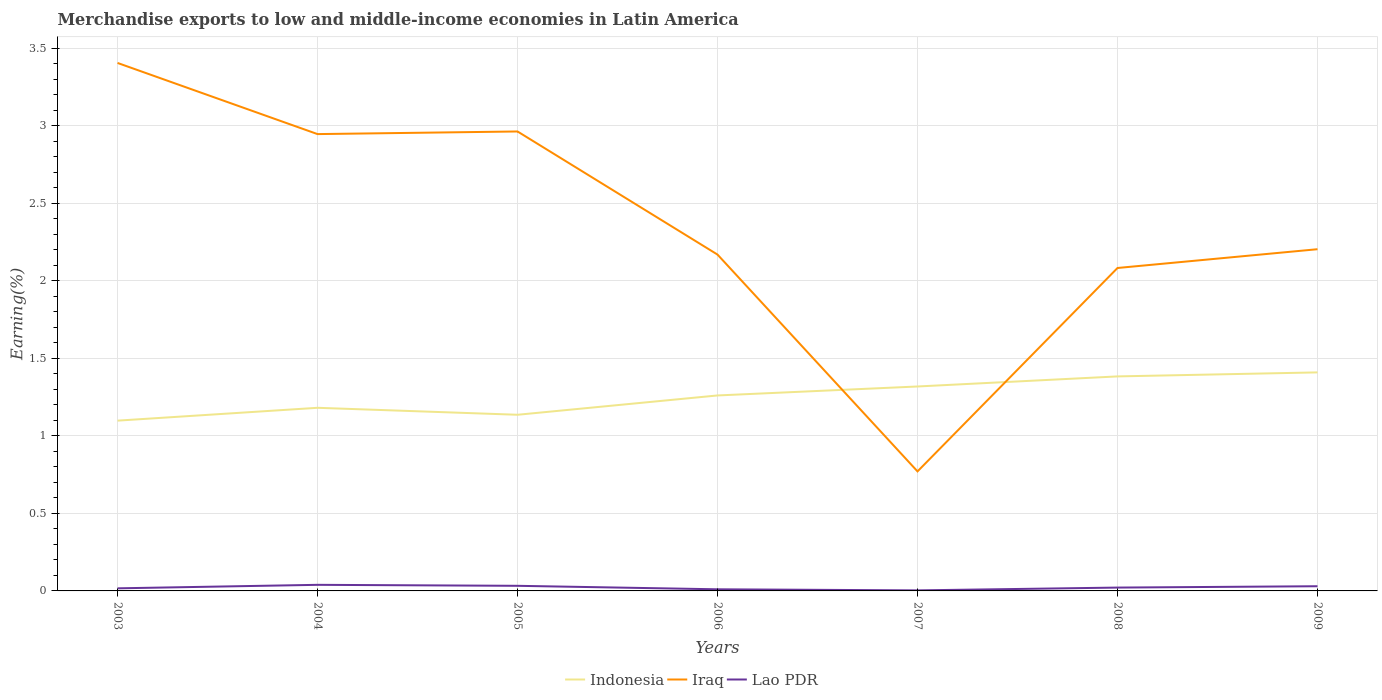Is the number of lines equal to the number of legend labels?
Make the answer very short. Yes. Across all years, what is the maximum percentage of amount earned from merchandise exports in Lao PDR?
Ensure brevity in your answer.  0. What is the total percentage of amount earned from merchandise exports in Iraq in the graph?
Your answer should be very brief. 2.63. What is the difference between the highest and the second highest percentage of amount earned from merchandise exports in Lao PDR?
Keep it short and to the point. 0.04. Is the percentage of amount earned from merchandise exports in Indonesia strictly greater than the percentage of amount earned from merchandise exports in Lao PDR over the years?
Provide a short and direct response. No. How many lines are there?
Make the answer very short. 3. How many years are there in the graph?
Your answer should be compact. 7. Does the graph contain any zero values?
Give a very brief answer. No. Does the graph contain grids?
Your answer should be compact. Yes. Where does the legend appear in the graph?
Give a very brief answer. Bottom center. How are the legend labels stacked?
Give a very brief answer. Horizontal. What is the title of the graph?
Your response must be concise. Merchandise exports to low and middle-income economies in Latin America. What is the label or title of the Y-axis?
Keep it short and to the point. Earning(%). What is the Earning(%) of Indonesia in 2003?
Provide a short and direct response. 1.1. What is the Earning(%) of Iraq in 2003?
Provide a short and direct response. 3.41. What is the Earning(%) in Lao PDR in 2003?
Your answer should be very brief. 0.02. What is the Earning(%) in Indonesia in 2004?
Provide a short and direct response. 1.18. What is the Earning(%) of Iraq in 2004?
Ensure brevity in your answer.  2.95. What is the Earning(%) of Lao PDR in 2004?
Keep it short and to the point. 0.04. What is the Earning(%) of Indonesia in 2005?
Your response must be concise. 1.14. What is the Earning(%) in Iraq in 2005?
Provide a short and direct response. 2.96. What is the Earning(%) of Lao PDR in 2005?
Offer a terse response. 0.03. What is the Earning(%) in Indonesia in 2006?
Your answer should be compact. 1.26. What is the Earning(%) of Iraq in 2006?
Offer a very short reply. 2.17. What is the Earning(%) in Lao PDR in 2006?
Provide a short and direct response. 0.01. What is the Earning(%) of Indonesia in 2007?
Give a very brief answer. 1.32. What is the Earning(%) in Iraq in 2007?
Your answer should be very brief. 0.77. What is the Earning(%) in Lao PDR in 2007?
Offer a terse response. 0. What is the Earning(%) of Indonesia in 2008?
Offer a very short reply. 1.38. What is the Earning(%) of Iraq in 2008?
Offer a terse response. 2.08. What is the Earning(%) of Lao PDR in 2008?
Provide a short and direct response. 0.02. What is the Earning(%) in Indonesia in 2009?
Keep it short and to the point. 1.41. What is the Earning(%) of Iraq in 2009?
Your answer should be compact. 2.2. What is the Earning(%) of Lao PDR in 2009?
Your response must be concise. 0.03. Across all years, what is the maximum Earning(%) of Indonesia?
Your response must be concise. 1.41. Across all years, what is the maximum Earning(%) of Iraq?
Your answer should be very brief. 3.41. Across all years, what is the maximum Earning(%) of Lao PDR?
Ensure brevity in your answer.  0.04. Across all years, what is the minimum Earning(%) in Indonesia?
Your response must be concise. 1.1. Across all years, what is the minimum Earning(%) of Iraq?
Give a very brief answer. 0.77. Across all years, what is the minimum Earning(%) of Lao PDR?
Your response must be concise. 0. What is the total Earning(%) of Indonesia in the graph?
Keep it short and to the point. 8.79. What is the total Earning(%) in Iraq in the graph?
Make the answer very short. 16.54. What is the total Earning(%) in Lao PDR in the graph?
Offer a very short reply. 0.15. What is the difference between the Earning(%) of Indonesia in 2003 and that in 2004?
Provide a short and direct response. -0.08. What is the difference between the Earning(%) in Iraq in 2003 and that in 2004?
Provide a short and direct response. 0.46. What is the difference between the Earning(%) of Lao PDR in 2003 and that in 2004?
Provide a short and direct response. -0.02. What is the difference between the Earning(%) of Indonesia in 2003 and that in 2005?
Keep it short and to the point. -0.04. What is the difference between the Earning(%) of Iraq in 2003 and that in 2005?
Your answer should be very brief. 0.44. What is the difference between the Earning(%) of Lao PDR in 2003 and that in 2005?
Offer a very short reply. -0.02. What is the difference between the Earning(%) of Indonesia in 2003 and that in 2006?
Offer a terse response. -0.16. What is the difference between the Earning(%) of Iraq in 2003 and that in 2006?
Ensure brevity in your answer.  1.24. What is the difference between the Earning(%) in Lao PDR in 2003 and that in 2006?
Provide a succinct answer. 0.01. What is the difference between the Earning(%) in Indonesia in 2003 and that in 2007?
Make the answer very short. -0.22. What is the difference between the Earning(%) of Iraq in 2003 and that in 2007?
Your answer should be compact. 2.63. What is the difference between the Earning(%) in Lao PDR in 2003 and that in 2007?
Your answer should be compact. 0.01. What is the difference between the Earning(%) in Indonesia in 2003 and that in 2008?
Your answer should be very brief. -0.29. What is the difference between the Earning(%) in Iraq in 2003 and that in 2008?
Provide a succinct answer. 1.32. What is the difference between the Earning(%) in Lao PDR in 2003 and that in 2008?
Offer a terse response. -0. What is the difference between the Earning(%) in Indonesia in 2003 and that in 2009?
Your answer should be compact. -0.31. What is the difference between the Earning(%) of Iraq in 2003 and that in 2009?
Your response must be concise. 1.2. What is the difference between the Earning(%) of Lao PDR in 2003 and that in 2009?
Provide a short and direct response. -0.01. What is the difference between the Earning(%) in Indonesia in 2004 and that in 2005?
Keep it short and to the point. 0.04. What is the difference between the Earning(%) in Iraq in 2004 and that in 2005?
Provide a succinct answer. -0.02. What is the difference between the Earning(%) of Lao PDR in 2004 and that in 2005?
Offer a terse response. 0.01. What is the difference between the Earning(%) in Indonesia in 2004 and that in 2006?
Your answer should be compact. -0.08. What is the difference between the Earning(%) of Iraq in 2004 and that in 2006?
Your answer should be compact. 0.78. What is the difference between the Earning(%) of Lao PDR in 2004 and that in 2006?
Offer a terse response. 0.03. What is the difference between the Earning(%) of Indonesia in 2004 and that in 2007?
Your answer should be compact. -0.14. What is the difference between the Earning(%) in Iraq in 2004 and that in 2007?
Provide a succinct answer. 2.18. What is the difference between the Earning(%) in Lao PDR in 2004 and that in 2007?
Ensure brevity in your answer.  0.04. What is the difference between the Earning(%) in Indonesia in 2004 and that in 2008?
Your response must be concise. -0.2. What is the difference between the Earning(%) of Iraq in 2004 and that in 2008?
Keep it short and to the point. 0.86. What is the difference between the Earning(%) of Lao PDR in 2004 and that in 2008?
Provide a succinct answer. 0.02. What is the difference between the Earning(%) of Indonesia in 2004 and that in 2009?
Your answer should be compact. -0.23. What is the difference between the Earning(%) of Iraq in 2004 and that in 2009?
Keep it short and to the point. 0.74. What is the difference between the Earning(%) in Lao PDR in 2004 and that in 2009?
Your answer should be compact. 0.01. What is the difference between the Earning(%) in Indonesia in 2005 and that in 2006?
Offer a very short reply. -0.12. What is the difference between the Earning(%) of Iraq in 2005 and that in 2006?
Offer a terse response. 0.79. What is the difference between the Earning(%) of Lao PDR in 2005 and that in 2006?
Give a very brief answer. 0.02. What is the difference between the Earning(%) in Indonesia in 2005 and that in 2007?
Keep it short and to the point. -0.18. What is the difference between the Earning(%) in Iraq in 2005 and that in 2007?
Your answer should be compact. 2.19. What is the difference between the Earning(%) in Lao PDR in 2005 and that in 2007?
Offer a terse response. 0.03. What is the difference between the Earning(%) of Indonesia in 2005 and that in 2008?
Ensure brevity in your answer.  -0.25. What is the difference between the Earning(%) in Iraq in 2005 and that in 2008?
Keep it short and to the point. 0.88. What is the difference between the Earning(%) in Lao PDR in 2005 and that in 2008?
Ensure brevity in your answer.  0.01. What is the difference between the Earning(%) in Indonesia in 2005 and that in 2009?
Offer a terse response. -0.27. What is the difference between the Earning(%) of Iraq in 2005 and that in 2009?
Make the answer very short. 0.76. What is the difference between the Earning(%) in Lao PDR in 2005 and that in 2009?
Keep it short and to the point. 0. What is the difference between the Earning(%) of Indonesia in 2006 and that in 2007?
Offer a very short reply. -0.06. What is the difference between the Earning(%) in Iraq in 2006 and that in 2007?
Ensure brevity in your answer.  1.4. What is the difference between the Earning(%) of Lao PDR in 2006 and that in 2007?
Offer a terse response. 0.01. What is the difference between the Earning(%) in Indonesia in 2006 and that in 2008?
Your answer should be compact. -0.12. What is the difference between the Earning(%) of Iraq in 2006 and that in 2008?
Offer a very short reply. 0.09. What is the difference between the Earning(%) of Lao PDR in 2006 and that in 2008?
Your answer should be compact. -0.01. What is the difference between the Earning(%) in Indonesia in 2006 and that in 2009?
Provide a short and direct response. -0.15. What is the difference between the Earning(%) of Iraq in 2006 and that in 2009?
Keep it short and to the point. -0.03. What is the difference between the Earning(%) in Lao PDR in 2006 and that in 2009?
Provide a succinct answer. -0.02. What is the difference between the Earning(%) in Indonesia in 2007 and that in 2008?
Give a very brief answer. -0.07. What is the difference between the Earning(%) of Iraq in 2007 and that in 2008?
Keep it short and to the point. -1.31. What is the difference between the Earning(%) of Lao PDR in 2007 and that in 2008?
Your response must be concise. -0.02. What is the difference between the Earning(%) of Indonesia in 2007 and that in 2009?
Give a very brief answer. -0.09. What is the difference between the Earning(%) of Iraq in 2007 and that in 2009?
Keep it short and to the point. -1.43. What is the difference between the Earning(%) of Lao PDR in 2007 and that in 2009?
Give a very brief answer. -0.03. What is the difference between the Earning(%) of Indonesia in 2008 and that in 2009?
Provide a succinct answer. -0.03. What is the difference between the Earning(%) of Iraq in 2008 and that in 2009?
Provide a short and direct response. -0.12. What is the difference between the Earning(%) of Lao PDR in 2008 and that in 2009?
Provide a succinct answer. -0.01. What is the difference between the Earning(%) of Indonesia in 2003 and the Earning(%) of Iraq in 2004?
Give a very brief answer. -1.85. What is the difference between the Earning(%) in Indonesia in 2003 and the Earning(%) in Lao PDR in 2004?
Keep it short and to the point. 1.06. What is the difference between the Earning(%) in Iraq in 2003 and the Earning(%) in Lao PDR in 2004?
Keep it short and to the point. 3.37. What is the difference between the Earning(%) of Indonesia in 2003 and the Earning(%) of Iraq in 2005?
Give a very brief answer. -1.87. What is the difference between the Earning(%) of Indonesia in 2003 and the Earning(%) of Lao PDR in 2005?
Make the answer very short. 1.07. What is the difference between the Earning(%) of Iraq in 2003 and the Earning(%) of Lao PDR in 2005?
Your response must be concise. 3.37. What is the difference between the Earning(%) in Indonesia in 2003 and the Earning(%) in Iraq in 2006?
Ensure brevity in your answer.  -1.07. What is the difference between the Earning(%) of Indonesia in 2003 and the Earning(%) of Lao PDR in 2006?
Provide a short and direct response. 1.09. What is the difference between the Earning(%) in Iraq in 2003 and the Earning(%) in Lao PDR in 2006?
Keep it short and to the point. 3.4. What is the difference between the Earning(%) in Indonesia in 2003 and the Earning(%) in Iraq in 2007?
Keep it short and to the point. 0.33. What is the difference between the Earning(%) in Indonesia in 2003 and the Earning(%) in Lao PDR in 2007?
Keep it short and to the point. 1.09. What is the difference between the Earning(%) in Iraq in 2003 and the Earning(%) in Lao PDR in 2007?
Make the answer very short. 3.4. What is the difference between the Earning(%) of Indonesia in 2003 and the Earning(%) of Iraq in 2008?
Your answer should be very brief. -0.98. What is the difference between the Earning(%) of Indonesia in 2003 and the Earning(%) of Lao PDR in 2008?
Offer a very short reply. 1.08. What is the difference between the Earning(%) in Iraq in 2003 and the Earning(%) in Lao PDR in 2008?
Give a very brief answer. 3.38. What is the difference between the Earning(%) of Indonesia in 2003 and the Earning(%) of Iraq in 2009?
Make the answer very short. -1.11. What is the difference between the Earning(%) of Indonesia in 2003 and the Earning(%) of Lao PDR in 2009?
Provide a succinct answer. 1.07. What is the difference between the Earning(%) in Iraq in 2003 and the Earning(%) in Lao PDR in 2009?
Ensure brevity in your answer.  3.38. What is the difference between the Earning(%) of Indonesia in 2004 and the Earning(%) of Iraq in 2005?
Offer a terse response. -1.78. What is the difference between the Earning(%) in Indonesia in 2004 and the Earning(%) in Lao PDR in 2005?
Offer a terse response. 1.15. What is the difference between the Earning(%) of Iraq in 2004 and the Earning(%) of Lao PDR in 2005?
Your response must be concise. 2.91. What is the difference between the Earning(%) in Indonesia in 2004 and the Earning(%) in Iraq in 2006?
Provide a short and direct response. -0.99. What is the difference between the Earning(%) of Indonesia in 2004 and the Earning(%) of Lao PDR in 2006?
Make the answer very short. 1.17. What is the difference between the Earning(%) of Iraq in 2004 and the Earning(%) of Lao PDR in 2006?
Offer a terse response. 2.94. What is the difference between the Earning(%) of Indonesia in 2004 and the Earning(%) of Iraq in 2007?
Make the answer very short. 0.41. What is the difference between the Earning(%) in Indonesia in 2004 and the Earning(%) in Lao PDR in 2007?
Your response must be concise. 1.18. What is the difference between the Earning(%) in Iraq in 2004 and the Earning(%) in Lao PDR in 2007?
Give a very brief answer. 2.94. What is the difference between the Earning(%) of Indonesia in 2004 and the Earning(%) of Iraq in 2008?
Keep it short and to the point. -0.9. What is the difference between the Earning(%) of Indonesia in 2004 and the Earning(%) of Lao PDR in 2008?
Your answer should be compact. 1.16. What is the difference between the Earning(%) of Iraq in 2004 and the Earning(%) of Lao PDR in 2008?
Ensure brevity in your answer.  2.93. What is the difference between the Earning(%) in Indonesia in 2004 and the Earning(%) in Iraq in 2009?
Provide a short and direct response. -1.02. What is the difference between the Earning(%) of Indonesia in 2004 and the Earning(%) of Lao PDR in 2009?
Offer a terse response. 1.15. What is the difference between the Earning(%) in Iraq in 2004 and the Earning(%) in Lao PDR in 2009?
Offer a terse response. 2.92. What is the difference between the Earning(%) of Indonesia in 2005 and the Earning(%) of Iraq in 2006?
Your response must be concise. -1.03. What is the difference between the Earning(%) of Indonesia in 2005 and the Earning(%) of Lao PDR in 2006?
Give a very brief answer. 1.13. What is the difference between the Earning(%) of Iraq in 2005 and the Earning(%) of Lao PDR in 2006?
Give a very brief answer. 2.95. What is the difference between the Earning(%) of Indonesia in 2005 and the Earning(%) of Iraq in 2007?
Your response must be concise. 0.37. What is the difference between the Earning(%) in Indonesia in 2005 and the Earning(%) in Lao PDR in 2007?
Your response must be concise. 1.13. What is the difference between the Earning(%) of Iraq in 2005 and the Earning(%) of Lao PDR in 2007?
Offer a very short reply. 2.96. What is the difference between the Earning(%) of Indonesia in 2005 and the Earning(%) of Iraq in 2008?
Your response must be concise. -0.95. What is the difference between the Earning(%) of Indonesia in 2005 and the Earning(%) of Lao PDR in 2008?
Offer a terse response. 1.11. What is the difference between the Earning(%) in Iraq in 2005 and the Earning(%) in Lao PDR in 2008?
Ensure brevity in your answer.  2.94. What is the difference between the Earning(%) of Indonesia in 2005 and the Earning(%) of Iraq in 2009?
Your answer should be compact. -1.07. What is the difference between the Earning(%) in Indonesia in 2005 and the Earning(%) in Lao PDR in 2009?
Ensure brevity in your answer.  1.11. What is the difference between the Earning(%) of Iraq in 2005 and the Earning(%) of Lao PDR in 2009?
Provide a short and direct response. 2.93. What is the difference between the Earning(%) in Indonesia in 2006 and the Earning(%) in Iraq in 2007?
Offer a terse response. 0.49. What is the difference between the Earning(%) in Indonesia in 2006 and the Earning(%) in Lao PDR in 2007?
Your answer should be very brief. 1.26. What is the difference between the Earning(%) of Iraq in 2006 and the Earning(%) of Lao PDR in 2007?
Give a very brief answer. 2.17. What is the difference between the Earning(%) in Indonesia in 2006 and the Earning(%) in Iraq in 2008?
Offer a very short reply. -0.82. What is the difference between the Earning(%) of Indonesia in 2006 and the Earning(%) of Lao PDR in 2008?
Ensure brevity in your answer.  1.24. What is the difference between the Earning(%) of Iraq in 2006 and the Earning(%) of Lao PDR in 2008?
Offer a terse response. 2.15. What is the difference between the Earning(%) in Indonesia in 2006 and the Earning(%) in Iraq in 2009?
Offer a terse response. -0.94. What is the difference between the Earning(%) of Indonesia in 2006 and the Earning(%) of Lao PDR in 2009?
Ensure brevity in your answer.  1.23. What is the difference between the Earning(%) of Iraq in 2006 and the Earning(%) of Lao PDR in 2009?
Provide a short and direct response. 2.14. What is the difference between the Earning(%) of Indonesia in 2007 and the Earning(%) of Iraq in 2008?
Your answer should be compact. -0.76. What is the difference between the Earning(%) in Indonesia in 2007 and the Earning(%) in Lao PDR in 2008?
Offer a very short reply. 1.3. What is the difference between the Earning(%) of Iraq in 2007 and the Earning(%) of Lao PDR in 2008?
Ensure brevity in your answer.  0.75. What is the difference between the Earning(%) in Indonesia in 2007 and the Earning(%) in Iraq in 2009?
Your answer should be very brief. -0.89. What is the difference between the Earning(%) in Indonesia in 2007 and the Earning(%) in Lao PDR in 2009?
Keep it short and to the point. 1.29. What is the difference between the Earning(%) in Iraq in 2007 and the Earning(%) in Lao PDR in 2009?
Offer a terse response. 0.74. What is the difference between the Earning(%) of Indonesia in 2008 and the Earning(%) of Iraq in 2009?
Your answer should be compact. -0.82. What is the difference between the Earning(%) of Indonesia in 2008 and the Earning(%) of Lao PDR in 2009?
Provide a succinct answer. 1.35. What is the difference between the Earning(%) of Iraq in 2008 and the Earning(%) of Lao PDR in 2009?
Your answer should be very brief. 2.05. What is the average Earning(%) of Indonesia per year?
Your answer should be compact. 1.26. What is the average Earning(%) of Iraq per year?
Keep it short and to the point. 2.36. What is the average Earning(%) in Lao PDR per year?
Offer a very short reply. 0.02. In the year 2003, what is the difference between the Earning(%) in Indonesia and Earning(%) in Iraq?
Your answer should be very brief. -2.31. In the year 2003, what is the difference between the Earning(%) in Indonesia and Earning(%) in Lao PDR?
Make the answer very short. 1.08. In the year 2003, what is the difference between the Earning(%) of Iraq and Earning(%) of Lao PDR?
Offer a very short reply. 3.39. In the year 2004, what is the difference between the Earning(%) in Indonesia and Earning(%) in Iraq?
Offer a very short reply. -1.77. In the year 2004, what is the difference between the Earning(%) in Indonesia and Earning(%) in Lao PDR?
Provide a short and direct response. 1.14. In the year 2004, what is the difference between the Earning(%) of Iraq and Earning(%) of Lao PDR?
Offer a very short reply. 2.91. In the year 2005, what is the difference between the Earning(%) of Indonesia and Earning(%) of Iraq?
Your answer should be very brief. -1.83. In the year 2005, what is the difference between the Earning(%) in Indonesia and Earning(%) in Lao PDR?
Provide a succinct answer. 1.1. In the year 2005, what is the difference between the Earning(%) of Iraq and Earning(%) of Lao PDR?
Offer a terse response. 2.93. In the year 2006, what is the difference between the Earning(%) in Indonesia and Earning(%) in Iraq?
Offer a terse response. -0.91. In the year 2006, what is the difference between the Earning(%) of Indonesia and Earning(%) of Lao PDR?
Your response must be concise. 1.25. In the year 2006, what is the difference between the Earning(%) in Iraq and Earning(%) in Lao PDR?
Provide a short and direct response. 2.16. In the year 2007, what is the difference between the Earning(%) of Indonesia and Earning(%) of Iraq?
Give a very brief answer. 0.55. In the year 2007, what is the difference between the Earning(%) in Indonesia and Earning(%) in Lao PDR?
Offer a very short reply. 1.32. In the year 2007, what is the difference between the Earning(%) of Iraq and Earning(%) of Lao PDR?
Your answer should be very brief. 0.77. In the year 2008, what is the difference between the Earning(%) in Indonesia and Earning(%) in Iraq?
Your answer should be compact. -0.7. In the year 2008, what is the difference between the Earning(%) of Indonesia and Earning(%) of Lao PDR?
Offer a very short reply. 1.36. In the year 2008, what is the difference between the Earning(%) of Iraq and Earning(%) of Lao PDR?
Give a very brief answer. 2.06. In the year 2009, what is the difference between the Earning(%) in Indonesia and Earning(%) in Iraq?
Keep it short and to the point. -0.79. In the year 2009, what is the difference between the Earning(%) of Indonesia and Earning(%) of Lao PDR?
Keep it short and to the point. 1.38. In the year 2009, what is the difference between the Earning(%) of Iraq and Earning(%) of Lao PDR?
Your response must be concise. 2.17. What is the ratio of the Earning(%) of Indonesia in 2003 to that in 2004?
Provide a short and direct response. 0.93. What is the ratio of the Earning(%) of Iraq in 2003 to that in 2004?
Keep it short and to the point. 1.16. What is the ratio of the Earning(%) in Lao PDR in 2003 to that in 2004?
Your answer should be very brief. 0.43. What is the ratio of the Earning(%) in Indonesia in 2003 to that in 2005?
Keep it short and to the point. 0.97. What is the ratio of the Earning(%) of Iraq in 2003 to that in 2005?
Keep it short and to the point. 1.15. What is the ratio of the Earning(%) of Lao PDR in 2003 to that in 2005?
Make the answer very short. 0.51. What is the ratio of the Earning(%) of Indonesia in 2003 to that in 2006?
Make the answer very short. 0.87. What is the ratio of the Earning(%) of Iraq in 2003 to that in 2006?
Ensure brevity in your answer.  1.57. What is the ratio of the Earning(%) in Lao PDR in 2003 to that in 2006?
Your response must be concise. 1.6. What is the ratio of the Earning(%) of Indonesia in 2003 to that in 2007?
Your answer should be compact. 0.83. What is the ratio of the Earning(%) in Iraq in 2003 to that in 2007?
Keep it short and to the point. 4.42. What is the ratio of the Earning(%) in Lao PDR in 2003 to that in 2007?
Provide a succinct answer. 4.77. What is the ratio of the Earning(%) of Indonesia in 2003 to that in 2008?
Offer a very short reply. 0.79. What is the ratio of the Earning(%) in Iraq in 2003 to that in 2008?
Provide a succinct answer. 1.63. What is the ratio of the Earning(%) of Lao PDR in 2003 to that in 2008?
Ensure brevity in your answer.  0.78. What is the ratio of the Earning(%) in Indonesia in 2003 to that in 2009?
Your answer should be compact. 0.78. What is the ratio of the Earning(%) of Iraq in 2003 to that in 2009?
Give a very brief answer. 1.55. What is the ratio of the Earning(%) of Lao PDR in 2003 to that in 2009?
Give a very brief answer. 0.55. What is the ratio of the Earning(%) in Indonesia in 2004 to that in 2005?
Make the answer very short. 1.04. What is the ratio of the Earning(%) in Iraq in 2004 to that in 2005?
Offer a very short reply. 0.99. What is the ratio of the Earning(%) of Lao PDR in 2004 to that in 2005?
Offer a very short reply. 1.19. What is the ratio of the Earning(%) in Indonesia in 2004 to that in 2006?
Your response must be concise. 0.94. What is the ratio of the Earning(%) in Iraq in 2004 to that in 2006?
Give a very brief answer. 1.36. What is the ratio of the Earning(%) of Lao PDR in 2004 to that in 2006?
Provide a succinct answer. 3.76. What is the ratio of the Earning(%) in Indonesia in 2004 to that in 2007?
Ensure brevity in your answer.  0.9. What is the ratio of the Earning(%) of Iraq in 2004 to that in 2007?
Offer a terse response. 3.82. What is the ratio of the Earning(%) of Lao PDR in 2004 to that in 2007?
Your answer should be compact. 11.21. What is the ratio of the Earning(%) of Indonesia in 2004 to that in 2008?
Keep it short and to the point. 0.85. What is the ratio of the Earning(%) of Iraq in 2004 to that in 2008?
Keep it short and to the point. 1.41. What is the ratio of the Earning(%) of Lao PDR in 2004 to that in 2008?
Provide a succinct answer. 1.82. What is the ratio of the Earning(%) of Indonesia in 2004 to that in 2009?
Your response must be concise. 0.84. What is the ratio of the Earning(%) in Iraq in 2004 to that in 2009?
Offer a terse response. 1.34. What is the ratio of the Earning(%) in Lao PDR in 2004 to that in 2009?
Provide a succinct answer. 1.3. What is the ratio of the Earning(%) in Indonesia in 2005 to that in 2006?
Ensure brevity in your answer.  0.9. What is the ratio of the Earning(%) in Iraq in 2005 to that in 2006?
Keep it short and to the point. 1.37. What is the ratio of the Earning(%) of Lao PDR in 2005 to that in 2006?
Your response must be concise. 3.15. What is the ratio of the Earning(%) of Indonesia in 2005 to that in 2007?
Your answer should be very brief. 0.86. What is the ratio of the Earning(%) of Iraq in 2005 to that in 2007?
Make the answer very short. 3.84. What is the ratio of the Earning(%) in Lao PDR in 2005 to that in 2007?
Provide a short and direct response. 9.4. What is the ratio of the Earning(%) of Indonesia in 2005 to that in 2008?
Make the answer very short. 0.82. What is the ratio of the Earning(%) in Iraq in 2005 to that in 2008?
Offer a very short reply. 1.42. What is the ratio of the Earning(%) in Lao PDR in 2005 to that in 2008?
Provide a short and direct response. 1.53. What is the ratio of the Earning(%) in Indonesia in 2005 to that in 2009?
Ensure brevity in your answer.  0.81. What is the ratio of the Earning(%) of Iraq in 2005 to that in 2009?
Offer a terse response. 1.34. What is the ratio of the Earning(%) in Lao PDR in 2005 to that in 2009?
Keep it short and to the point. 1.09. What is the ratio of the Earning(%) in Indonesia in 2006 to that in 2007?
Provide a succinct answer. 0.96. What is the ratio of the Earning(%) of Iraq in 2006 to that in 2007?
Keep it short and to the point. 2.81. What is the ratio of the Earning(%) of Lao PDR in 2006 to that in 2007?
Keep it short and to the point. 2.98. What is the ratio of the Earning(%) of Indonesia in 2006 to that in 2008?
Your response must be concise. 0.91. What is the ratio of the Earning(%) of Iraq in 2006 to that in 2008?
Give a very brief answer. 1.04. What is the ratio of the Earning(%) of Lao PDR in 2006 to that in 2008?
Provide a short and direct response. 0.48. What is the ratio of the Earning(%) in Indonesia in 2006 to that in 2009?
Offer a terse response. 0.89. What is the ratio of the Earning(%) of Iraq in 2006 to that in 2009?
Your response must be concise. 0.98. What is the ratio of the Earning(%) in Lao PDR in 2006 to that in 2009?
Offer a very short reply. 0.35. What is the ratio of the Earning(%) in Indonesia in 2007 to that in 2008?
Keep it short and to the point. 0.95. What is the ratio of the Earning(%) of Iraq in 2007 to that in 2008?
Offer a very short reply. 0.37. What is the ratio of the Earning(%) in Lao PDR in 2007 to that in 2008?
Your answer should be compact. 0.16. What is the ratio of the Earning(%) in Indonesia in 2007 to that in 2009?
Give a very brief answer. 0.94. What is the ratio of the Earning(%) in Iraq in 2007 to that in 2009?
Keep it short and to the point. 0.35. What is the ratio of the Earning(%) in Lao PDR in 2007 to that in 2009?
Offer a terse response. 0.12. What is the ratio of the Earning(%) of Indonesia in 2008 to that in 2009?
Give a very brief answer. 0.98. What is the ratio of the Earning(%) in Iraq in 2008 to that in 2009?
Ensure brevity in your answer.  0.95. What is the ratio of the Earning(%) in Lao PDR in 2008 to that in 2009?
Provide a short and direct response. 0.71. What is the difference between the highest and the second highest Earning(%) in Indonesia?
Provide a succinct answer. 0.03. What is the difference between the highest and the second highest Earning(%) of Iraq?
Your answer should be very brief. 0.44. What is the difference between the highest and the second highest Earning(%) in Lao PDR?
Keep it short and to the point. 0.01. What is the difference between the highest and the lowest Earning(%) in Indonesia?
Give a very brief answer. 0.31. What is the difference between the highest and the lowest Earning(%) in Iraq?
Make the answer very short. 2.63. What is the difference between the highest and the lowest Earning(%) of Lao PDR?
Keep it short and to the point. 0.04. 